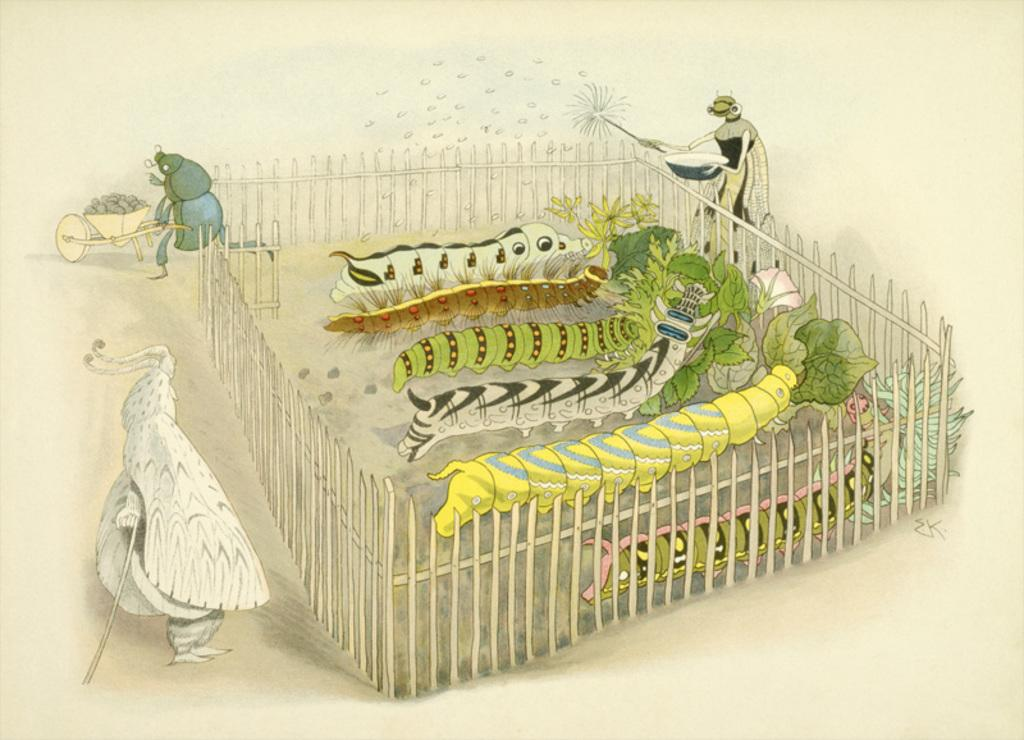What is located in the center of the image? There are worms in the center of the image. What else can be seen in the image besides worms? There are plants, a fence, a trolley, and flies in the image. What might be used to keep animals or people within a specific area in the image? The fence in the image might be used to keep animals or people within a specific area. What insects are present in the image? Flies are present in the image. What type of caption is written on the trolley in the image? There is no caption written on the trolley in the image. What flavor of mint can be seen growing in the image? There is no mint present in the image. 